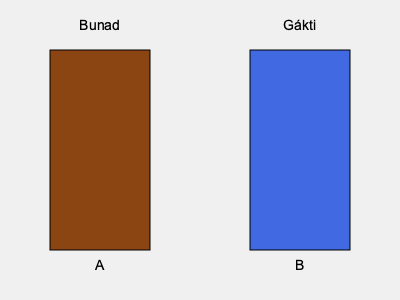Which of the illustrated traditional Norwegian clothing items is most commonly associated with the majority of the Norwegian population? To answer this question, we need to consider the following steps:

1. Identify the two clothing items shown in the illustration:
   A) Bunad
   B) Gákti

2. Understand the cultural context of each item:
   - Bunad: A traditional Norwegian folk costume worn by many Norwegians on special occasions.
   - Gákti: A traditional Sami costume, worn by the indigenous Sami people of northern Scandinavia.

3. Consider the demographics of Norway:
   - The majority of Norway's population is ethnically Norwegian.
   - The Sami people are a minority group in Norway.

4. Analyze which item is more widely associated with Norwegian culture:
   - The Bunad is worn throughout Norway by people of various backgrounds.
   - The Gákti is specific to the Sami culture and less common in the general Norwegian population.

5. Conclude that the Bunad (A) is more commonly associated with the majority of the Norwegian population due to its widespread use across the country.
Answer: Bunad 